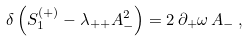<formula> <loc_0><loc_0><loc_500><loc_500>\delta \left ( S _ { 1 } ^ { ( + ) } - \lambda _ { + + } A _ { - } ^ { 2 } \right ) = 2 \, \partial _ { + } \omega \, A _ { - } \, ,</formula> 